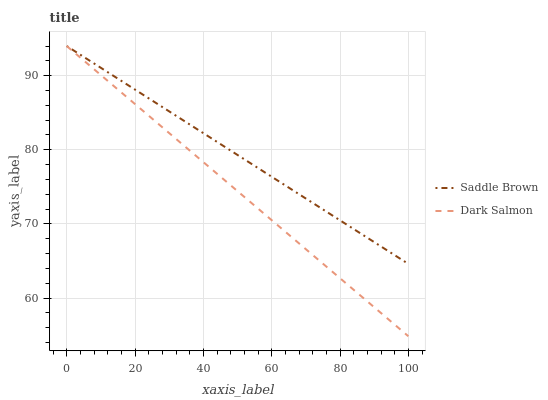Does Dark Salmon have the minimum area under the curve?
Answer yes or no. Yes. Does Saddle Brown have the maximum area under the curve?
Answer yes or no. Yes. Does Dark Salmon have the maximum area under the curve?
Answer yes or no. No. Is Saddle Brown the smoothest?
Answer yes or no. Yes. Is Dark Salmon the roughest?
Answer yes or no. Yes. Is Dark Salmon the smoothest?
Answer yes or no. No. Does Dark Salmon have the lowest value?
Answer yes or no. Yes. Does Dark Salmon have the highest value?
Answer yes or no. Yes. Does Saddle Brown intersect Dark Salmon?
Answer yes or no. Yes. Is Saddle Brown less than Dark Salmon?
Answer yes or no. No. Is Saddle Brown greater than Dark Salmon?
Answer yes or no. No. 